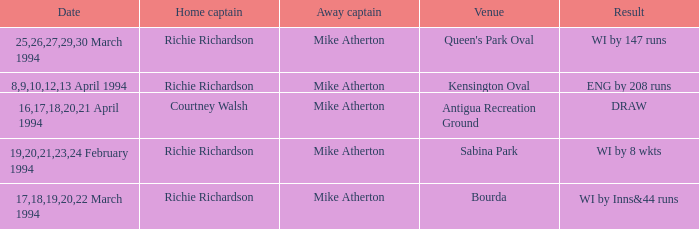What is the Venue which has a Wi by 8 wkts? Sabina Park. 